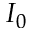Convert formula to latex. <formula><loc_0><loc_0><loc_500><loc_500>I _ { 0 }</formula> 